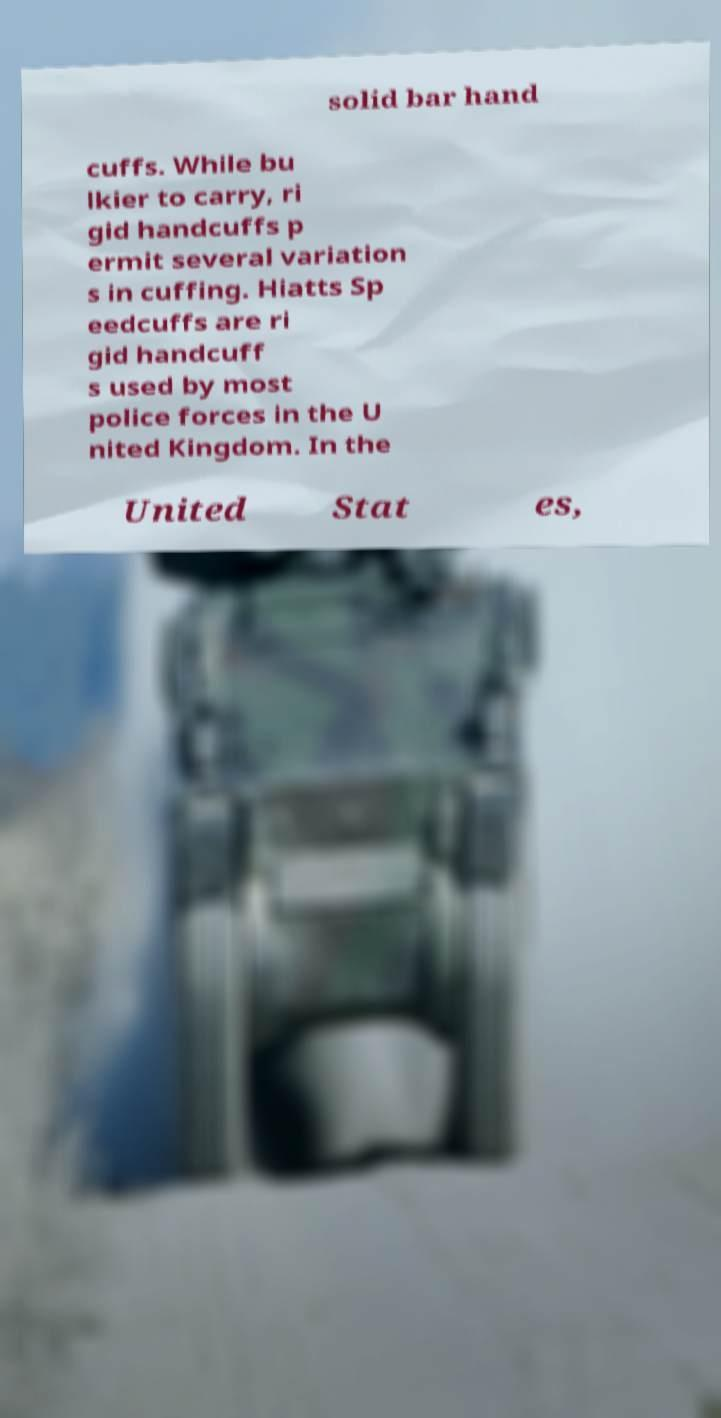I need the written content from this picture converted into text. Can you do that? solid bar hand cuffs. While bu lkier to carry, ri gid handcuffs p ermit several variation s in cuffing. Hiatts Sp eedcuffs are ri gid handcuff s used by most police forces in the U nited Kingdom. In the United Stat es, 